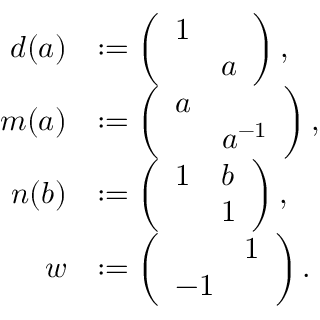Convert formula to latex. <formula><loc_0><loc_0><loc_500><loc_500>\begin{array} { r l } { d ( a ) } & { \colon = \left ( \begin{array} { l l } { 1 } & \\ & { a } \end{array} \right ) , } \\ { m ( a ) } & { \colon = \left ( \begin{array} { l l } { a } & \\ & { a ^ { - 1 } } \end{array} \right ) , } \\ { n ( b ) } & { \colon = \left ( \begin{array} { l l } { 1 } & { b } \\ & { 1 } \end{array} \right ) , } \\ { w } & { \colon = \left ( \begin{array} { l l } & { 1 } \\ { - 1 } & \end{array} \right ) . } \end{array}</formula> 